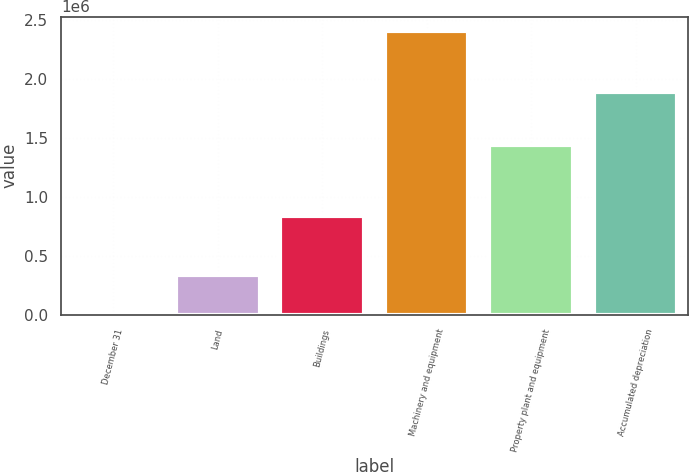Convert chart. <chart><loc_0><loc_0><loc_500><loc_500><bar_chart><fcel>December 31<fcel>Land<fcel>Buildings<fcel>Machinery and equipment<fcel>Property plant and equipment<fcel>Accumulated depreciation<nl><fcel>2010<fcel>334285<fcel>843094<fcel>2.41061e+06<fcel>1.4377e+06<fcel>1.88706e+06<nl></chart> 